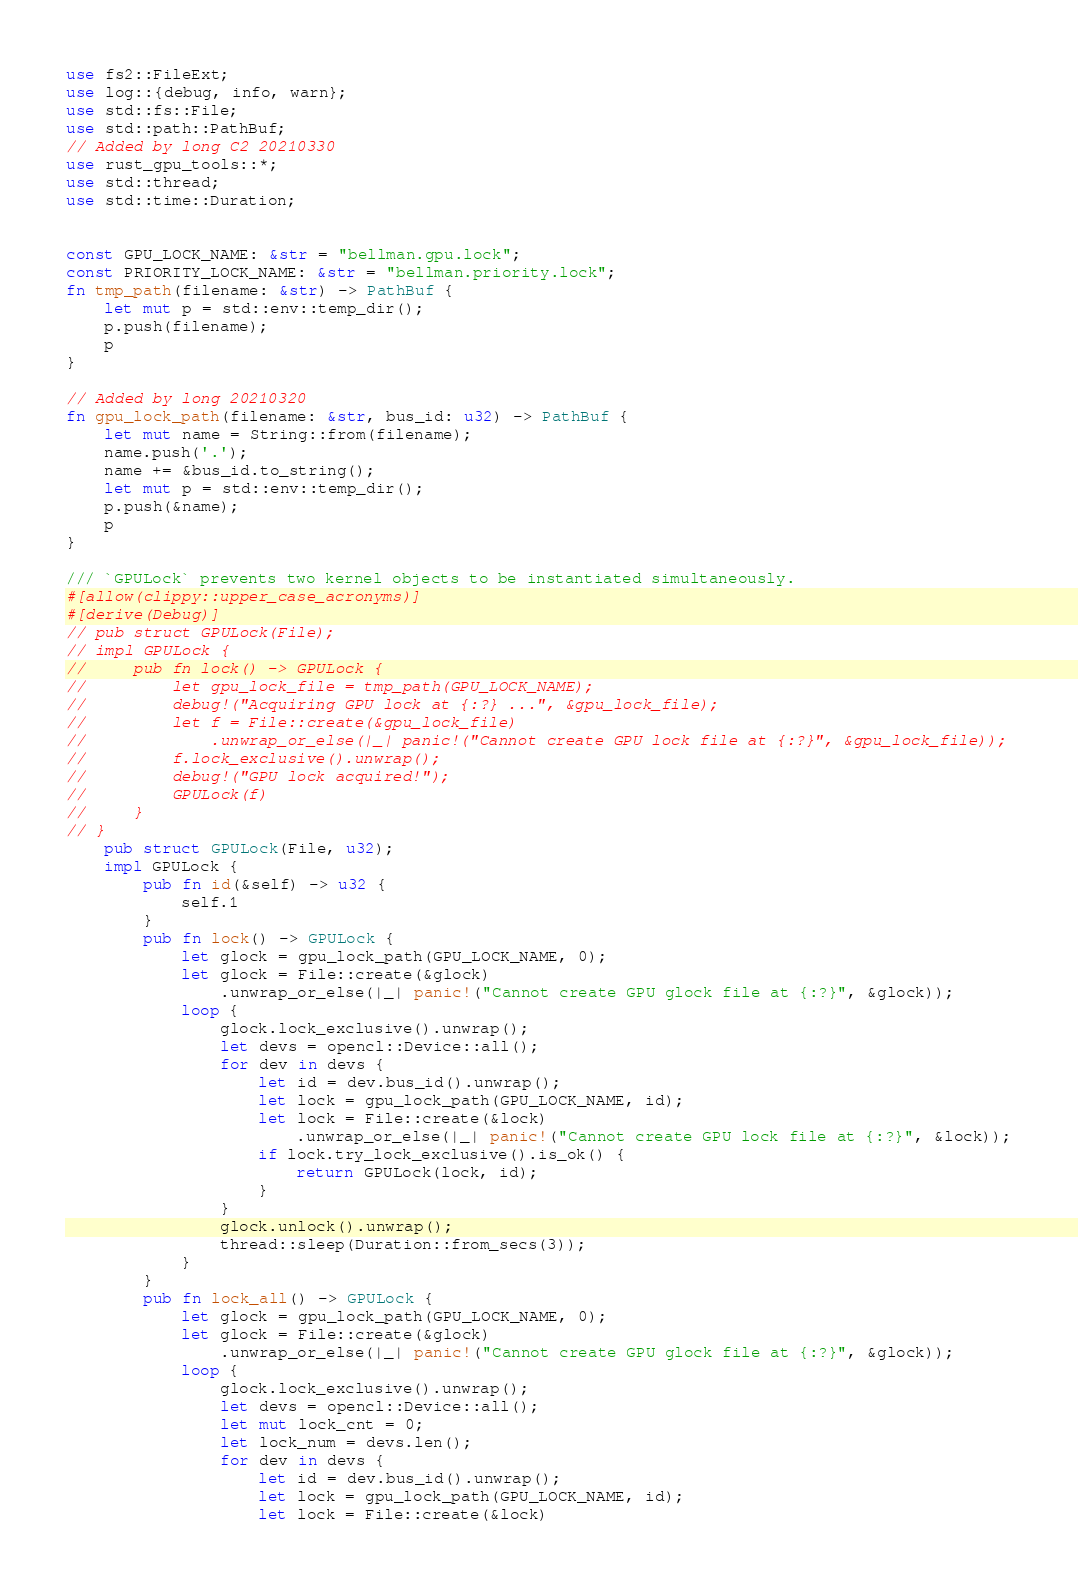Convert code to text. <code><loc_0><loc_0><loc_500><loc_500><_Rust_>use fs2::FileExt;
use log::{debug, info, warn};
use std::fs::File;
use std::path::PathBuf;
// Added by long C2 20210330
use rust_gpu_tools::*;
use std::thread;
use std::time::Duration;


const GPU_LOCK_NAME: &str = "bellman.gpu.lock";
const PRIORITY_LOCK_NAME: &str = "bellman.priority.lock";
fn tmp_path(filename: &str) -> PathBuf {
    let mut p = std::env::temp_dir();
    p.push(filename);
    p
}

// Added by long 20210320
fn gpu_lock_path(filename: &str, bus_id: u32) -> PathBuf {
    let mut name = String::from(filename);
    name.push('.');
    name += &bus_id.to_string();
    let mut p = std::env::temp_dir();
    p.push(&name);
    p
}

/// `GPULock` prevents two kernel objects to be instantiated simultaneously.
#[allow(clippy::upper_case_acronyms)]
#[derive(Debug)]
// pub struct GPULock(File);
// impl GPULock {
//     pub fn lock() -> GPULock {
//         let gpu_lock_file = tmp_path(GPU_LOCK_NAME);
//         debug!("Acquiring GPU lock at {:?} ...", &gpu_lock_file);
//         let f = File::create(&gpu_lock_file)
//             .unwrap_or_else(|_| panic!("Cannot create GPU lock file at {:?}", &gpu_lock_file));
//         f.lock_exclusive().unwrap();
//         debug!("GPU lock acquired!");
//         GPULock(f)
//     }
// }
    pub struct GPULock(File, u32);
    impl GPULock {
        pub fn id(&self) -> u32 {
            self.1
        }
        pub fn lock() -> GPULock {
            let glock = gpu_lock_path(GPU_LOCK_NAME, 0);
            let glock = File::create(&glock)
                .unwrap_or_else(|_| panic!("Cannot create GPU glock file at {:?}", &glock));
            loop {
                glock.lock_exclusive().unwrap();
                let devs = opencl::Device::all();
                for dev in devs {
                    let id = dev.bus_id().unwrap();
                    let lock = gpu_lock_path(GPU_LOCK_NAME, id);
                    let lock = File::create(&lock)
                        .unwrap_or_else(|_| panic!("Cannot create GPU lock file at {:?}", &lock));
                    if lock.try_lock_exclusive().is_ok() {
                        return GPULock(lock, id);
                    }
                }
                glock.unlock().unwrap();
                thread::sleep(Duration::from_secs(3));
            }
        }
        pub fn lock_all() -> GPULock {
            let glock = gpu_lock_path(GPU_LOCK_NAME, 0);
            let glock = File::create(&glock)
                .unwrap_or_else(|_| panic!("Cannot create GPU glock file at {:?}", &glock));
            loop {
                glock.lock_exclusive().unwrap();
                let devs = opencl::Device::all();
                let mut lock_cnt = 0;
                let lock_num = devs.len();
                for dev in devs {
                    let id = dev.bus_id().unwrap();
                    let lock = gpu_lock_path(GPU_LOCK_NAME, id);
                    let lock = File::create(&lock)</code> 